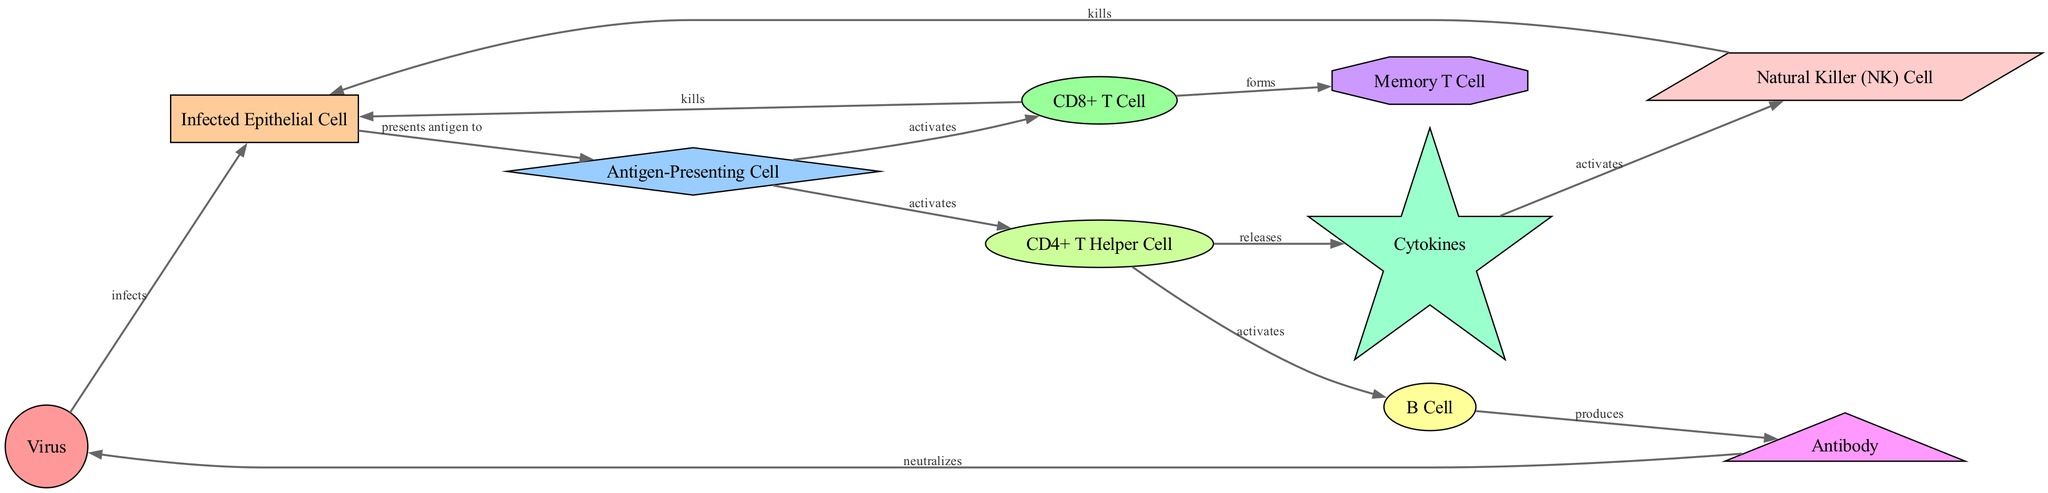What node infects the epithelial cell? According to the diagram, the arrow labeled "infects" originates from the "Virus" node and points to the "Infected Epithelial Cell" node, indicating that the virus is responsible for the infection.
Answer: Virus How many nodes are present in the diagram? The diagram contains a total of ten different nodes, which include Virus, Infected Epithelial Cell, Antigen-Presenting Cell, CD8+ T Cell, CD4+ T Helper Cell, B Cell, Antibody, Memory T Cell, Cytokines, and Natural Killer Cell.
Answer: Ten What does the CD4+ T Helper Cell activate? The diagram shows that the CD4+ T Helper Cell has two outgoing arrows that activate both the B Cell and the CD8+ T Cell, as indicated by the labels on the edges connecting these nodes.
Answer: B Cell and CD8+ T Cell What is the relationship between antibodies and the virus? The diagram indicates a connection where the Antibody node has an arrow pointing towards the Virus node, labeled "neutralizes," demonstrating that antibodies function to neutralize the virus.
Answer: Neutralizes Which cell type is activated by cytokines? Looking at the diagram, there is an arrow from the Cytokines node pointing to the NK Cell node, which signifies that cytokines are involved in activating Natural Killer Cells within the immune response.
Answer: NK Cell What outcomes result from CD8+ T Cell activation? Based on the diagram flow, upon activation, the CD8+ T Cell either kills the Infected Epithelial Cell or forms Memory T Cells, as indicated by the two outgoing arrows from the CD8+ T Cell node.
Answer: Kills and forms How does an antigen-presenting cell activate a CD4+ T Helper Cell? The diagram illustrates that the Antigen-Presenting Cell presents the antigen to the CD4+ T Helper Cell, evidenced by the directed edge labeled "activates" between these two nodes, showing the activation mechanism.
Answer: Presents antigen to What is produced by B Cells? The directed edge from the B Cell to the Antibody node is labeled "produces," indicating that upon activation, B Cells generate antibodies as part of the immune response.
Answer: Antibody 